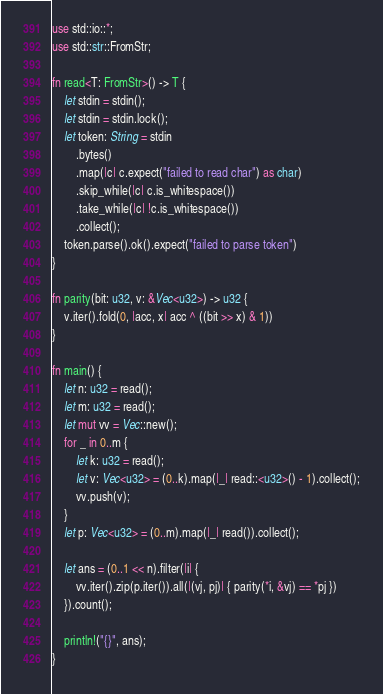<code> <loc_0><loc_0><loc_500><loc_500><_Rust_>use std::io::*;
use std::str::FromStr;

fn read<T: FromStr>() -> T {
    let stdin = stdin();
    let stdin = stdin.lock();
    let token: String = stdin
        .bytes()
        .map(|c| c.expect("failed to read char") as char)
        .skip_while(|c| c.is_whitespace())
        .take_while(|c| !c.is_whitespace())
        .collect();
    token.parse().ok().expect("failed to parse token")
}

fn parity(bit: u32, v: &Vec<u32>) -> u32 {
    v.iter().fold(0, |acc, x| acc ^ ((bit >> x) & 1))
}

fn main() {
    let n: u32 = read();
    let m: u32 = read();
    let mut vv = Vec::new();
    for _ in 0..m {
        let k: u32 = read();
        let v: Vec<u32> = (0..k).map(|_| read::<u32>() - 1).collect();
        vv.push(v);
    }
    let p: Vec<u32> = (0..m).map(|_| read()).collect();

    let ans = (0..1 << n).filter(|i| {
        vv.iter().zip(p.iter()).all(|(vj, pj)| { parity(*i, &vj) == *pj })
    }).count();

    println!("{}", ans);
}
</code> 